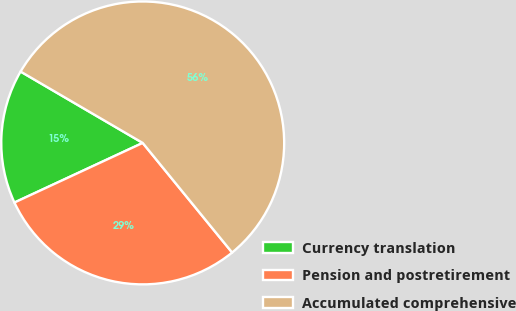Convert chart to OTSL. <chart><loc_0><loc_0><loc_500><loc_500><pie_chart><fcel>Currency translation<fcel>Pension and postretirement<fcel>Accumulated comprehensive<nl><fcel>15.34%<fcel>28.97%<fcel>55.69%<nl></chart> 